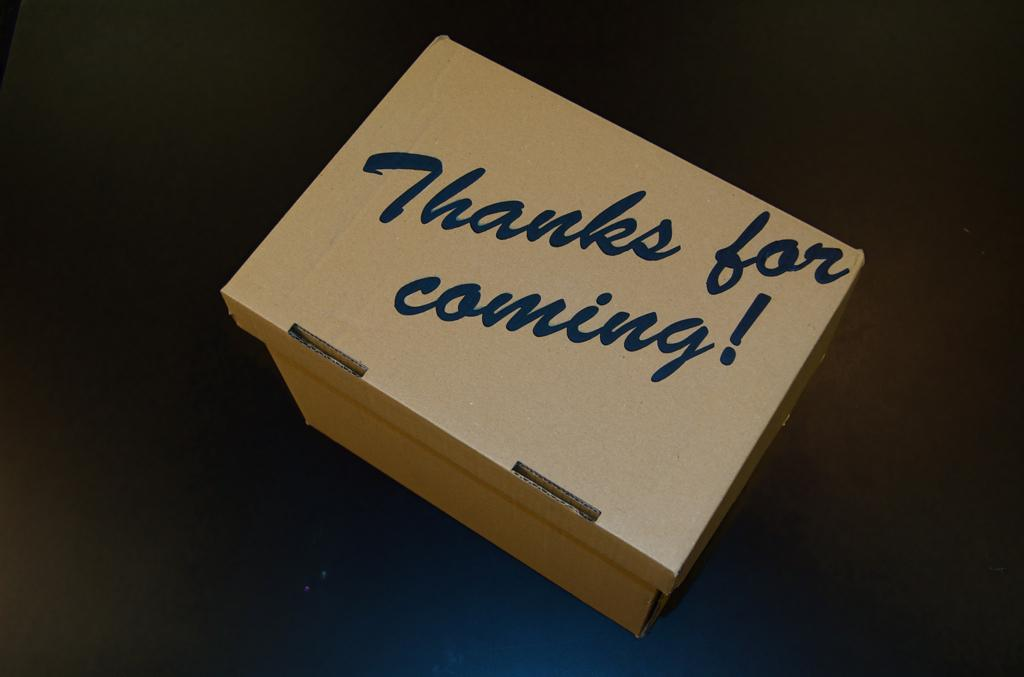<image>
Relay a brief, clear account of the picture shown. A white box with the words Thanks for Coming! on the lid. 